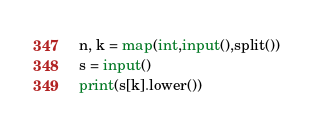<code> <loc_0><loc_0><loc_500><loc_500><_Python_>n, k = map(int,input(),split())
s = input()
print(s[k].lower())</code> 